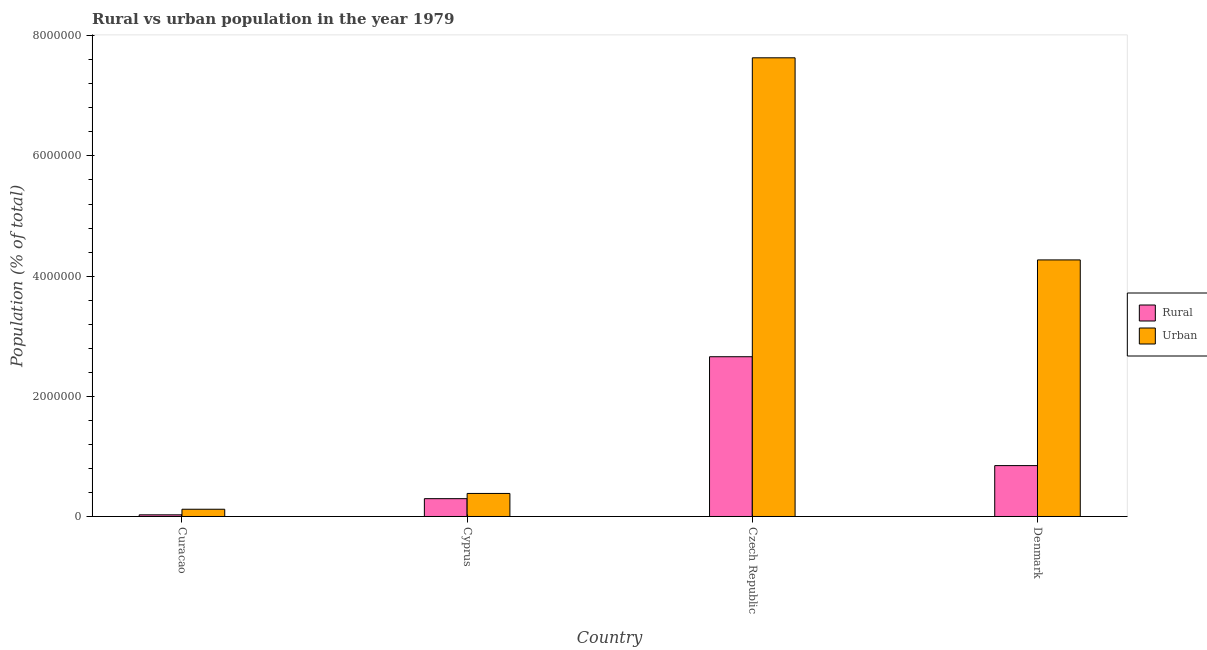How many bars are there on the 4th tick from the left?
Offer a terse response. 2. What is the label of the 1st group of bars from the left?
Offer a very short reply. Curacao. In how many cases, is the number of bars for a given country not equal to the number of legend labels?
Offer a terse response. 0. What is the rural population density in Cyprus?
Your answer should be very brief. 2.97e+05. Across all countries, what is the maximum rural population density?
Ensure brevity in your answer.  2.66e+06. Across all countries, what is the minimum rural population density?
Ensure brevity in your answer.  2.74e+04. In which country was the rural population density maximum?
Your response must be concise. Czech Republic. In which country was the urban population density minimum?
Make the answer very short. Curacao. What is the total urban population density in the graph?
Keep it short and to the point. 1.24e+07. What is the difference between the urban population density in Curacao and that in Cyprus?
Provide a short and direct response. -2.63e+05. What is the difference between the rural population density in Denmark and the urban population density in Cyprus?
Ensure brevity in your answer.  4.64e+05. What is the average urban population density per country?
Make the answer very short. 3.10e+06. What is the difference between the urban population density and rural population density in Czech Republic?
Offer a very short reply. 4.97e+06. What is the ratio of the rural population density in Curacao to that in Denmark?
Your answer should be very brief. 0.03. What is the difference between the highest and the second highest rural population density?
Make the answer very short. 1.81e+06. What is the difference between the highest and the lowest urban population density?
Keep it short and to the point. 7.51e+06. In how many countries, is the rural population density greater than the average rural population density taken over all countries?
Provide a short and direct response. 1. What does the 1st bar from the left in Czech Republic represents?
Your answer should be compact. Rural. What does the 1st bar from the right in Cyprus represents?
Ensure brevity in your answer.  Urban. How many bars are there?
Keep it short and to the point. 8. How many countries are there in the graph?
Offer a very short reply. 4. What is the difference between two consecutive major ticks on the Y-axis?
Your answer should be compact. 2.00e+06. Are the values on the major ticks of Y-axis written in scientific E-notation?
Provide a short and direct response. No. Does the graph contain grids?
Offer a terse response. No. How many legend labels are there?
Your response must be concise. 2. What is the title of the graph?
Ensure brevity in your answer.  Rural vs urban population in the year 1979. Does "Food" appear as one of the legend labels in the graph?
Offer a terse response. No. What is the label or title of the X-axis?
Your response must be concise. Country. What is the label or title of the Y-axis?
Give a very brief answer. Population (% of total). What is the Population (% of total) of Rural in Curacao?
Provide a succinct answer. 2.74e+04. What is the Population (% of total) in Urban in Curacao?
Offer a very short reply. 1.20e+05. What is the Population (% of total) of Rural in Cyprus?
Offer a terse response. 2.97e+05. What is the Population (% of total) of Urban in Cyprus?
Provide a succinct answer. 3.83e+05. What is the Population (% of total) of Rural in Czech Republic?
Your response must be concise. 2.66e+06. What is the Population (% of total) in Urban in Czech Republic?
Your answer should be compact. 7.63e+06. What is the Population (% of total) of Rural in Denmark?
Offer a terse response. 8.47e+05. What is the Population (% of total) in Urban in Denmark?
Ensure brevity in your answer.  4.27e+06. Across all countries, what is the maximum Population (% of total) of Rural?
Your answer should be very brief. 2.66e+06. Across all countries, what is the maximum Population (% of total) of Urban?
Provide a succinct answer. 7.63e+06. Across all countries, what is the minimum Population (% of total) in Rural?
Keep it short and to the point. 2.74e+04. Across all countries, what is the minimum Population (% of total) in Urban?
Your answer should be compact. 1.20e+05. What is the total Population (% of total) in Rural in the graph?
Make the answer very short. 3.83e+06. What is the total Population (% of total) in Urban in the graph?
Offer a very short reply. 1.24e+07. What is the difference between the Population (% of total) of Rural in Curacao and that in Cyprus?
Ensure brevity in your answer.  -2.69e+05. What is the difference between the Population (% of total) in Urban in Curacao and that in Cyprus?
Your answer should be very brief. -2.63e+05. What is the difference between the Population (% of total) of Rural in Curacao and that in Czech Republic?
Ensure brevity in your answer.  -2.63e+06. What is the difference between the Population (% of total) in Urban in Curacao and that in Czech Republic?
Offer a very short reply. -7.51e+06. What is the difference between the Population (% of total) in Rural in Curacao and that in Denmark?
Keep it short and to the point. -8.20e+05. What is the difference between the Population (% of total) of Urban in Curacao and that in Denmark?
Offer a very short reply. -4.15e+06. What is the difference between the Population (% of total) of Rural in Cyprus and that in Czech Republic?
Make the answer very short. -2.36e+06. What is the difference between the Population (% of total) in Urban in Cyprus and that in Czech Republic?
Ensure brevity in your answer.  -7.25e+06. What is the difference between the Population (% of total) of Rural in Cyprus and that in Denmark?
Offer a terse response. -5.50e+05. What is the difference between the Population (% of total) in Urban in Cyprus and that in Denmark?
Your answer should be compact. -3.89e+06. What is the difference between the Population (% of total) in Rural in Czech Republic and that in Denmark?
Offer a very short reply. 1.81e+06. What is the difference between the Population (% of total) in Urban in Czech Republic and that in Denmark?
Offer a very short reply. 3.36e+06. What is the difference between the Population (% of total) in Rural in Curacao and the Population (% of total) in Urban in Cyprus?
Keep it short and to the point. -3.56e+05. What is the difference between the Population (% of total) of Rural in Curacao and the Population (% of total) of Urban in Czech Republic?
Your response must be concise. -7.61e+06. What is the difference between the Population (% of total) in Rural in Curacao and the Population (% of total) in Urban in Denmark?
Provide a short and direct response. -4.24e+06. What is the difference between the Population (% of total) of Rural in Cyprus and the Population (% of total) of Urban in Czech Republic?
Provide a short and direct response. -7.34e+06. What is the difference between the Population (% of total) of Rural in Cyprus and the Population (% of total) of Urban in Denmark?
Ensure brevity in your answer.  -3.97e+06. What is the difference between the Population (% of total) of Rural in Czech Republic and the Population (% of total) of Urban in Denmark?
Your answer should be compact. -1.61e+06. What is the average Population (% of total) of Rural per country?
Your response must be concise. 9.57e+05. What is the average Population (% of total) in Urban per country?
Your response must be concise. 3.10e+06. What is the difference between the Population (% of total) in Rural and Population (% of total) in Urban in Curacao?
Offer a very short reply. -9.30e+04. What is the difference between the Population (% of total) in Rural and Population (% of total) in Urban in Cyprus?
Your answer should be very brief. -8.67e+04. What is the difference between the Population (% of total) of Rural and Population (% of total) of Urban in Czech Republic?
Give a very brief answer. -4.97e+06. What is the difference between the Population (% of total) in Rural and Population (% of total) in Urban in Denmark?
Provide a succinct answer. -3.42e+06. What is the ratio of the Population (% of total) in Rural in Curacao to that in Cyprus?
Give a very brief answer. 0.09. What is the ratio of the Population (% of total) of Urban in Curacao to that in Cyprus?
Keep it short and to the point. 0.31. What is the ratio of the Population (% of total) in Rural in Curacao to that in Czech Republic?
Keep it short and to the point. 0.01. What is the ratio of the Population (% of total) of Urban in Curacao to that in Czech Republic?
Keep it short and to the point. 0.02. What is the ratio of the Population (% of total) of Rural in Curacao to that in Denmark?
Provide a succinct answer. 0.03. What is the ratio of the Population (% of total) of Urban in Curacao to that in Denmark?
Ensure brevity in your answer.  0.03. What is the ratio of the Population (% of total) of Rural in Cyprus to that in Czech Republic?
Your answer should be very brief. 0.11. What is the ratio of the Population (% of total) in Urban in Cyprus to that in Czech Republic?
Give a very brief answer. 0.05. What is the ratio of the Population (% of total) in Rural in Cyprus to that in Denmark?
Offer a terse response. 0.35. What is the ratio of the Population (% of total) of Urban in Cyprus to that in Denmark?
Offer a terse response. 0.09. What is the ratio of the Population (% of total) in Rural in Czech Republic to that in Denmark?
Offer a very short reply. 3.14. What is the ratio of the Population (% of total) in Urban in Czech Republic to that in Denmark?
Ensure brevity in your answer.  1.79. What is the difference between the highest and the second highest Population (% of total) in Rural?
Offer a very short reply. 1.81e+06. What is the difference between the highest and the second highest Population (% of total) of Urban?
Keep it short and to the point. 3.36e+06. What is the difference between the highest and the lowest Population (% of total) in Rural?
Your answer should be compact. 2.63e+06. What is the difference between the highest and the lowest Population (% of total) in Urban?
Your answer should be compact. 7.51e+06. 